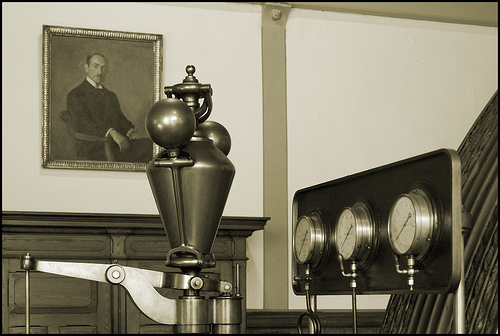<image>
Can you confirm if the portrait is to the right of the table? No. The portrait is not to the right of the table. The horizontal positioning shows a different relationship. 